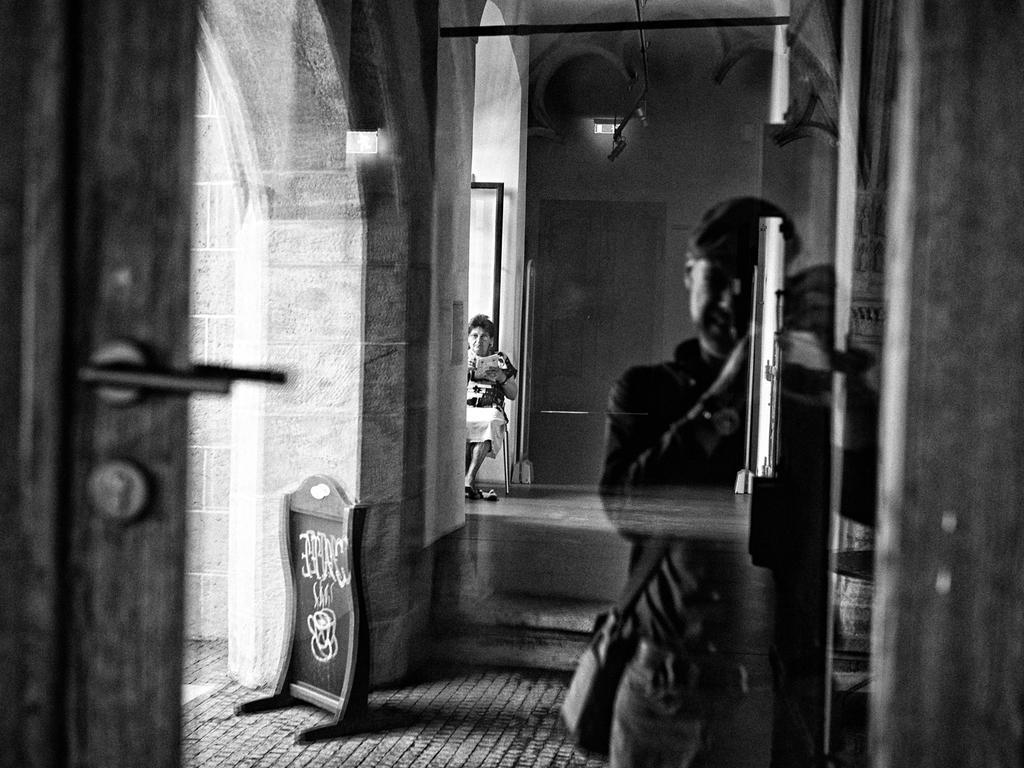Please provide a concise description of this image. Far this woman is sitting on a chair and holding an object. We can see a lights, board and door with handle. Front this man wore bag. 